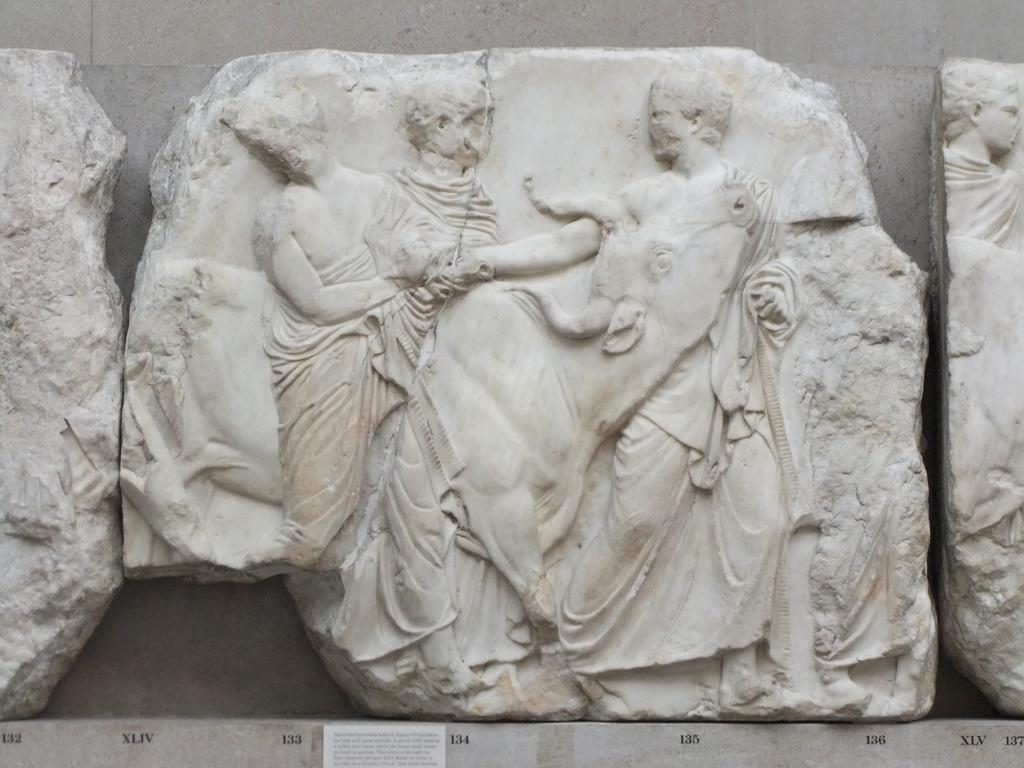Can you describe this image briefly? In this picture we can observe a carving on the white color stone placed here. In the background there is a wall. 